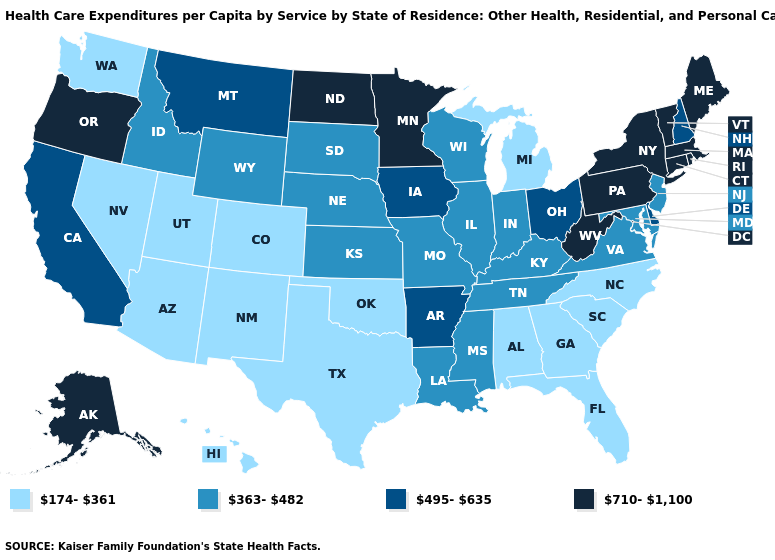Name the states that have a value in the range 363-482?
Be succinct. Idaho, Illinois, Indiana, Kansas, Kentucky, Louisiana, Maryland, Mississippi, Missouri, Nebraska, New Jersey, South Dakota, Tennessee, Virginia, Wisconsin, Wyoming. Does Maryland have the same value as Missouri?
Quick response, please. Yes. What is the value of Massachusetts?
Be succinct. 710-1,100. What is the value of Indiana?
Quick response, please. 363-482. What is the value of Wyoming?
Keep it brief. 363-482. Among the states that border Utah , which have the highest value?
Give a very brief answer. Idaho, Wyoming. How many symbols are there in the legend?
Quick response, please. 4. Name the states that have a value in the range 495-635?
Be succinct. Arkansas, California, Delaware, Iowa, Montana, New Hampshire, Ohio. Is the legend a continuous bar?
Keep it brief. No. What is the value of Maine?
Write a very short answer. 710-1,100. What is the value of New Hampshire?
Answer briefly. 495-635. Does the map have missing data?
Answer briefly. No. What is the lowest value in the USA?
Short answer required. 174-361. Among the states that border Connecticut , which have the lowest value?
Give a very brief answer. Massachusetts, New York, Rhode Island. Among the states that border Maryland , does Pennsylvania have the highest value?
Quick response, please. Yes. 